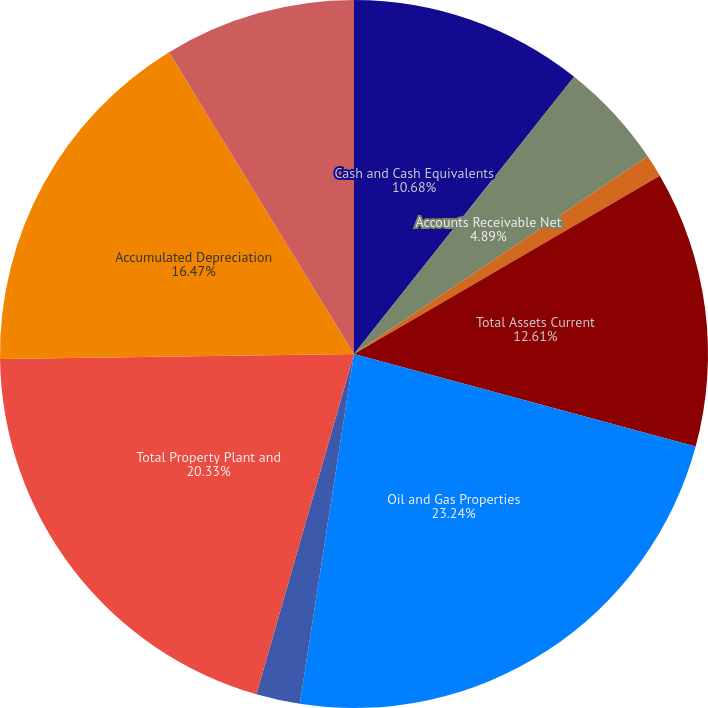Convert chart to OTSL. <chart><loc_0><loc_0><loc_500><loc_500><pie_chart><fcel>Cash and Cash Equivalents<fcel>Accounts Receivable Net<fcel>Other Current Assets<fcel>Total Assets Current<fcel>Oil and Gas Properties<fcel>Property Plant and Equipment<fcel>Total Property Plant and<fcel>Accumulated Depreciation<fcel>Goodwill<nl><fcel>10.68%<fcel>4.89%<fcel>1.03%<fcel>12.61%<fcel>23.23%<fcel>2.0%<fcel>20.33%<fcel>16.47%<fcel>8.75%<nl></chart> 